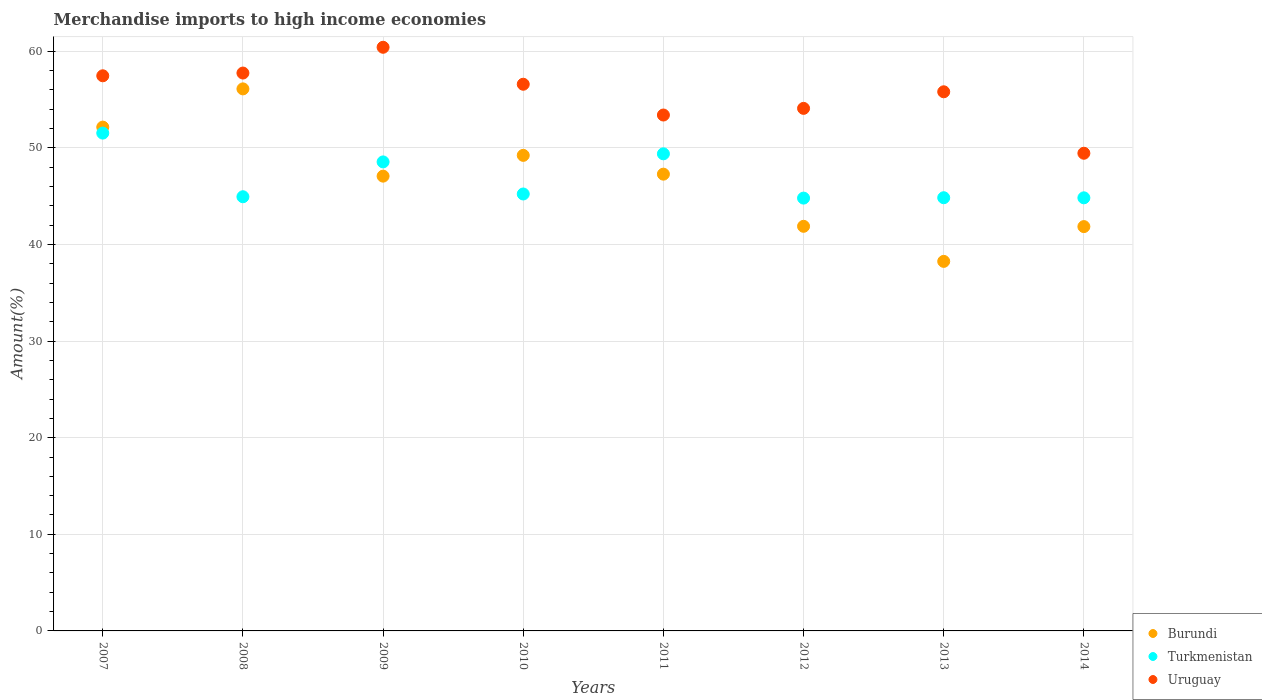How many different coloured dotlines are there?
Ensure brevity in your answer.  3. What is the percentage of amount earned from merchandise imports in Burundi in 2010?
Offer a very short reply. 49.22. Across all years, what is the maximum percentage of amount earned from merchandise imports in Burundi?
Ensure brevity in your answer.  56.1. Across all years, what is the minimum percentage of amount earned from merchandise imports in Uruguay?
Keep it short and to the point. 49.44. In which year was the percentage of amount earned from merchandise imports in Uruguay maximum?
Your answer should be very brief. 2009. What is the total percentage of amount earned from merchandise imports in Burundi in the graph?
Give a very brief answer. 373.78. What is the difference between the percentage of amount earned from merchandise imports in Uruguay in 2008 and that in 2011?
Make the answer very short. 4.34. What is the difference between the percentage of amount earned from merchandise imports in Burundi in 2013 and the percentage of amount earned from merchandise imports in Uruguay in 2012?
Your answer should be very brief. -15.84. What is the average percentage of amount earned from merchandise imports in Burundi per year?
Give a very brief answer. 46.72. In the year 2007, what is the difference between the percentage of amount earned from merchandise imports in Uruguay and percentage of amount earned from merchandise imports in Burundi?
Make the answer very short. 5.31. What is the ratio of the percentage of amount earned from merchandise imports in Turkmenistan in 2010 to that in 2014?
Make the answer very short. 1.01. Is the percentage of amount earned from merchandise imports in Burundi in 2013 less than that in 2014?
Provide a succinct answer. Yes. What is the difference between the highest and the second highest percentage of amount earned from merchandise imports in Turkmenistan?
Make the answer very short. 2.14. What is the difference between the highest and the lowest percentage of amount earned from merchandise imports in Uruguay?
Your answer should be compact. 10.97. In how many years, is the percentage of amount earned from merchandise imports in Burundi greater than the average percentage of amount earned from merchandise imports in Burundi taken over all years?
Make the answer very short. 5. Is the sum of the percentage of amount earned from merchandise imports in Burundi in 2011 and 2013 greater than the maximum percentage of amount earned from merchandise imports in Turkmenistan across all years?
Offer a terse response. Yes. Does the percentage of amount earned from merchandise imports in Turkmenistan monotonically increase over the years?
Your answer should be compact. No. Is the percentage of amount earned from merchandise imports in Uruguay strictly greater than the percentage of amount earned from merchandise imports in Burundi over the years?
Your response must be concise. Yes. How many dotlines are there?
Offer a very short reply. 3. What is the title of the graph?
Offer a very short reply. Merchandise imports to high income economies. Does "United Arab Emirates" appear as one of the legend labels in the graph?
Offer a terse response. No. What is the label or title of the Y-axis?
Your answer should be very brief. Amount(%). What is the Amount(%) in Burundi in 2007?
Provide a succinct answer. 52.14. What is the Amount(%) of Turkmenistan in 2007?
Your answer should be very brief. 51.52. What is the Amount(%) of Uruguay in 2007?
Your answer should be very brief. 57.46. What is the Amount(%) of Burundi in 2008?
Make the answer very short. 56.1. What is the Amount(%) of Turkmenistan in 2008?
Your response must be concise. 44.94. What is the Amount(%) in Uruguay in 2008?
Ensure brevity in your answer.  57.74. What is the Amount(%) in Burundi in 2009?
Your answer should be very brief. 47.07. What is the Amount(%) of Turkmenistan in 2009?
Offer a terse response. 48.54. What is the Amount(%) in Uruguay in 2009?
Ensure brevity in your answer.  60.41. What is the Amount(%) in Burundi in 2010?
Offer a very short reply. 49.22. What is the Amount(%) in Turkmenistan in 2010?
Provide a short and direct response. 45.22. What is the Amount(%) of Uruguay in 2010?
Keep it short and to the point. 56.58. What is the Amount(%) of Burundi in 2011?
Offer a very short reply. 47.27. What is the Amount(%) of Turkmenistan in 2011?
Offer a terse response. 49.38. What is the Amount(%) of Uruguay in 2011?
Offer a very short reply. 53.39. What is the Amount(%) in Burundi in 2012?
Provide a succinct answer. 41.88. What is the Amount(%) of Turkmenistan in 2012?
Provide a succinct answer. 44.8. What is the Amount(%) of Uruguay in 2012?
Make the answer very short. 54.08. What is the Amount(%) of Burundi in 2013?
Your response must be concise. 38.25. What is the Amount(%) of Turkmenistan in 2013?
Ensure brevity in your answer.  44.84. What is the Amount(%) in Uruguay in 2013?
Your response must be concise. 55.8. What is the Amount(%) in Burundi in 2014?
Your answer should be compact. 41.85. What is the Amount(%) in Turkmenistan in 2014?
Your response must be concise. 44.83. What is the Amount(%) in Uruguay in 2014?
Provide a short and direct response. 49.44. Across all years, what is the maximum Amount(%) of Burundi?
Offer a very short reply. 56.1. Across all years, what is the maximum Amount(%) of Turkmenistan?
Your answer should be very brief. 51.52. Across all years, what is the maximum Amount(%) of Uruguay?
Provide a short and direct response. 60.41. Across all years, what is the minimum Amount(%) in Burundi?
Your answer should be compact. 38.25. Across all years, what is the minimum Amount(%) of Turkmenistan?
Your answer should be compact. 44.8. Across all years, what is the minimum Amount(%) in Uruguay?
Your answer should be compact. 49.44. What is the total Amount(%) of Burundi in the graph?
Offer a terse response. 373.78. What is the total Amount(%) in Turkmenistan in the graph?
Ensure brevity in your answer.  374.06. What is the total Amount(%) in Uruguay in the graph?
Keep it short and to the point. 444.9. What is the difference between the Amount(%) of Burundi in 2007 and that in 2008?
Offer a very short reply. -3.96. What is the difference between the Amount(%) of Turkmenistan in 2007 and that in 2008?
Offer a very short reply. 6.59. What is the difference between the Amount(%) of Uruguay in 2007 and that in 2008?
Give a very brief answer. -0.28. What is the difference between the Amount(%) in Burundi in 2007 and that in 2009?
Your answer should be very brief. 5.07. What is the difference between the Amount(%) in Turkmenistan in 2007 and that in 2009?
Your answer should be very brief. 2.98. What is the difference between the Amount(%) of Uruguay in 2007 and that in 2009?
Offer a very short reply. -2.95. What is the difference between the Amount(%) of Burundi in 2007 and that in 2010?
Keep it short and to the point. 2.92. What is the difference between the Amount(%) in Turkmenistan in 2007 and that in 2010?
Offer a terse response. 6.3. What is the difference between the Amount(%) in Uruguay in 2007 and that in 2010?
Offer a very short reply. 0.88. What is the difference between the Amount(%) of Burundi in 2007 and that in 2011?
Offer a terse response. 4.87. What is the difference between the Amount(%) of Turkmenistan in 2007 and that in 2011?
Your response must be concise. 2.14. What is the difference between the Amount(%) of Uruguay in 2007 and that in 2011?
Provide a succinct answer. 4.06. What is the difference between the Amount(%) of Burundi in 2007 and that in 2012?
Your answer should be compact. 10.27. What is the difference between the Amount(%) in Turkmenistan in 2007 and that in 2012?
Your answer should be very brief. 6.73. What is the difference between the Amount(%) of Uruguay in 2007 and that in 2012?
Offer a very short reply. 3.37. What is the difference between the Amount(%) in Burundi in 2007 and that in 2013?
Offer a very short reply. 13.9. What is the difference between the Amount(%) in Turkmenistan in 2007 and that in 2013?
Keep it short and to the point. 6.69. What is the difference between the Amount(%) in Uruguay in 2007 and that in 2013?
Provide a short and direct response. 1.66. What is the difference between the Amount(%) of Burundi in 2007 and that in 2014?
Keep it short and to the point. 10.3. What is the difference between the Amount(%) of Turkmenistan in 2007 and that in 2014?
Offer a terse response. 6.7. What is the difference between the Amount(%) of Uruguay in 2007 and that in 2014?
Keep it short and to the point. 8.02. What is the difference between the Amount(%) in Burundi in 2008 and that in 2009?
Provide a short and direct response. 9.03. What is the difference between the Amount(%) in Turkmenistan in 2008 and that in 2009?
Your response must be concise. -3.61. What is the difference between the Amount(%) of Uruguay in 2008 and that in 2009?
Your response must be concise. -2.67. What is the difference between the Amount(%) of Burundi in 2008 and that in 2010?
Provide a short and direct response. 6.88. What is the difference between the Amount(%) of Turkmenistan in 2008 and that in 2010?
Offer a terse response. -0.29. What is the difference between the Amount(%) in Uruguay in 2008 and that in 2010?
Give a very brief answer. 1.16. What is the difference between the Amount(%) in Burundi in 2008 and that in 2011?
Give a very brief answer. 8.83. What is the difference between the Amount(%) of Turkmenistan in 2008 and that in 2011?
Your answer should be compact. -4.44. What is the difference between the Amount(%) in Uruguay in 2008 and that in 2011?
Provide a succinct answer. 4.34. What is the difference between the Amount(%) of Burundi in 2008 and that in 2012?
Provide a short and direct response. 14.22. What is the difference between the Amount(%) of Turkmenistan in 2008 and that in 2012?
Give a very brief answer. 0.14. What is the difference between the Amount(%) in Uruguay in 2008 and that in 2012?
Offer a terse response. 3.66. What is the difference between the Amount(%) in Burundi in 2008 and that in 2013?
Make the answer very short. 17.85. What is the difference between the Amount(%) in Turkmenistan in 2008 and that in 2013?
Give a very brief answer. 0.1. What is the difference between the Amount(%) of Uruguay in 2008 and that in 2013?
Your answer should be compact. 1.94. What is the difference between the Amount(%) of Burundi in 2008 and that in 2014?
Your response must be concise. 14.25. What is the difference between the Amount(%) of Turkmenistan in 2008 and that in 2014?
Your answer should be compact. 0.11. What is the difference between the Amount(%) of Uruguay in 2008 and that in 2014?
Provide a succinct answer. 8.3. What is the difference between the Amount(%) in Burundi in 2009 and that in 2010?
Keep it short and to the point. -2.15. What is the difference between the Amount(%) of Turkmenistan in 2009 and that in 2010?
Make the answer very short. 3.32. What is the difference between the Amount(%) in Uruguay in 2009 and that in 2010?
Keep it short and to the point. 3.83. What is the difference between the Amount(%) of Burundi in 2009 and that in 2011?
Keep it short and to the point. -0.2. What is the difference between the Amount(%) of Turkmenistan in 2009 and that in 2011?
Ensure brevity in your answer.  -0.84. What is the difference between the Amount(%) in Uruguay in 2009 and that in 2011?
Provide a short and direct response. 7.01. What is the difference between the Amount(%) of Burundi in 2009 and that in 2012?
Your answer should be very brief. 5.19. What is the difference between the Amount(%) in Turkmenistan in 2009 and that in 2012?
Make the answer very short. 3.75. What is the difference between the Amount(%) in Uruguay in 2009 and that in 2012?
Ensure brevity in your answer.  6.32. What is the difference between the Amount(%) of Burundi in 2009 and that in 2013?
Provide a succinct answer. 8.82. What is the difference between the Amount(%) of Turkmenistan in 2009 and that in 2013?
Offer a terse response. 3.71. What is the difference between the Amount(%) of Uruguay in 2009 and that in 2013?
Make the answer very short. 4.61. What is the difference between the Amount(%) of Burundi in 2009 and that in 2014?
Your response must be concise. 5.22. What is the difference between the Amount(%) of Turkmenistan in 2009 and that in 2014?
Ensure brevity in your answer.  3.72. What is the difference between the Amount(%) in Uruguay in 2009 and that in 2014?
Your response must be concise. 10.97. What is the difference between the Amount(%) of Burundi in 2010 and that in 2011?
Ensure brevity in your answer.  1.95. What is the difference between the Amount(%) of Turkmenistan in 2010 and that in 2011?
Your response must be concise. -4.16. What is the difference between the Amount(%) in Uruguay in 2010 and that in 2011?
Provide a succinct answer. 3.19. What is the difference between the Amount(%) in Burundi in 2010 and that in 2012?
Your answer should be compact. 7.34. What is the difference between the Amount(%) in Turkmenistan in 2010 and that in 2012?
Offer a terse response. 0.43. What is the difference between the Amount(%) in Uruguay in 2010 and that in 2012?
Your response must be concise. 2.5. What is the difference between the Amount(%) of Burundi in 2010 and that in 2013?
Offer a very short reply. 10.97. What is the difference between the Amount(%) of Turkmenistan in 2010 and that in 2013?
Provide a succinct answer. 0.39. What is the difference between the Amount(%) of Uruguay in 2010 and that in 2013?
Offer a terse response. 0.78. What is the difference between the Amount(%) of Burundi in 2010 and that in 2014?
Your response must be concise. 7.37. What is the difference between the Amount(%) in Turkmenistan in 2010 and that in 2014?
Your answer should be compact. 0.4. What is the difference between the Amount(%) of Uruguay in 2010 and that in 2014?
Ensure brevity in your answer.  7.14. What is the difference between the Amount(%) in Burundi in 2011 and that in 2012?
Make the answer very short. 5.4. What is the difference between the Amount(%) in Turkmenistan in 2011 and that in 2012?
Offer a terse response. 4.58. What is the difference between the Amount(%) of Uruguay in 2011 and that in 2012?
Provide a succinct answer. -0.69. What is the difference between the Amount(%) in Burundi in 2011 and that in 2013?
Provide a short and direct response. 9.03. What is the difference between the Amount(%) of Turkmenistan in 2011 and that in 2013?
Keep it short and to the point. 4.54. What is the difference between the Amount(%) in Uruguay in 2011 and that in 2013?
Give a very brief answer. -2.41. What is the difference between the Amount(%) of Burundi in 2011 and that in 2014?
Keep it short and to the point. 5.43. What is the difference between the Amount(%) of Turkmenistan in 2011 and that in 2014?
Your answer should be very brief. 4.55. What is the difference between the Amount(%) in Uruguay in 2011 and that in 2014?
Make the answer very short. 3.96. What is the difference between the Amount(%) in Burundi in 2012 and that in 2013?
Your answer should be very brief. 3.63. What is the difference between the Amount(%) of Turkmenistan in 2012 and that in 2013?
Offer a terse response. -0.04. What is the difference between the Amount(%) of Uruguay in 2012 and that in 2013?
Offer a terse response. -1.72. What is the difference between the Amount(%) in Burundi in 2012 and that in 2014?
Give a very brief answer. 0.03. What is the difference between the Amount(%) of Turkmenistan in 2012 and that in 2014?
Provide a short and direct response. -0.03. What is the difference between the Amount(%) of Uruguay in 2012 and that in 2014?
Provide a succinct answer. 4.65. What is the difference between the Amount(%) of Burundi in 2013 and that in 2014?
Keep it short and to the point. -3.6. What is the difference between the Amount(%) of Turkmenistan in 2013 and that in 2014?
Provide a succinct answer. 0.01. What is the difference between the Amount(%) in Uruguay in 2013 and that in 2014?
Your answer should be compact. 6.36. What is the difference between the Amount(%) in Burundi in 2007 and the Amount(%) in Turkmenistan in 2008?
Offer a terse response. 7.21. What is the difference between the Amount(%) of Burundi in 2007 and the Amount(%) of Uruguay in 2008?
Make the answer very short. -5.6. What is the difference between the Amount(%) in Turkmenistan in 2007 and the Amount(%) in Uruguay in 2008?
Make the answer very short. -6.22. What is the difference between the Amount(%) of Burundi in 2007 and the Amount(%) of Turkmenistan in 2009?
Offer a terse response. 3.6. What is the difference between the Amount(%) in Burundi in 2007 and the Amount(%) in Uruguay in 2009?
Make the answer very short. -8.26. What is the difference between the Amount(%) in Turkmenistan in 2007 and the Amount(%) in Uruguay in 2009?
Your answer should be very brief. -8.88. What is the difference between the Amount(%) of Burundi in 2007 and the Amount(%) of Turkmenistan in 2010?
Your response must be concise. 6.92. What is the difference between the Amount(%) in Burundi in 2007 and the Amount(%) in Uruguay in 2010?
Your answer should be very brief. -4.44. What is the difference between the Amount(%) of Turkmenistan in 2007 and the Amount(%) of Uruguay in 2010?
Offer a terse response. -5.06. What is the difference between the Amount(%) in Burundi in 2007 and the Amount(%) in Turkmenistan in 2011?
Provide a short and direct response. 2.76. What is the difference between the Amount(%) in Burundi in 2007 and the Amount(%) in Uruguay in 2011?
Provide a succinct answer. -1.25. What is the difference between the Amount(%) of Turkmenistan in 2007 and the Amount(%) of Uruguay in 2011?
Your answer should be compact. -1.87. What is the difference between the Amount(%) of Burundi in 2007 and the Amount(%) of Turkmenistan in 2012?
Provide a short and direct response. 7.35. What is the difference between the Amount(%) in Burundi in 2007 and the Amount(%) in Uruguay in 2012?
Keep it short and to the point. -1.94. What is the difference between the Amount(%) of Turkmenistan in 2007 and the Amount(%) of Uruguay in 2012?
Provide a short and direct response. -2.56. What is the difference between the Amount(%) of Burundi in 2007 and the Amount(%) of Turkmenistan in 2013?
Offer a very short reply. 7.31. What is the difference between the Amount(%) of Burundi in 2007 and the Amount(%) of Uruguay in 2013?
Ensure brevity in your answer.  -3.66. What is the difference between the Amount(%) of Turkmenistan in 2007 and the Amount(%) of Uruguay in 2013?
Offer a terse response. -4.28. What is the difference between the Amount(%) in Burundi in 2007 and the Amount(%) in Turkmenistan in 2014?
Your answer should be very brief. 7.32. What is the difference between the Amount(%) of Burundi in 2007 and the Amount(%) of Uruguay in 2014?
Offer a very short reply. 2.7. What is the difference between the Amount(%) of Turkmenistan in 2007 and the Amount(%) of Uruguay in 2014?
Offer a very short reply. 2.09. What is the difference between the Amount(%) in Burundi in 2008 and the Amount(%) in Turkmenistan in 2009?
Your answer should be very brief. 7.56. What is the difference between the Amount(%) in Burundi in 2008 and the Amount(%) in Uruguay in 2009?
Make the answer very short. -4.31. What is the difference between the Amount(%) in Turkmenistan in 2008 and the Amount(%) in Uruguay in 2009?
Your response must be concise. -15.47. What is the difference between the Amount(%) of Burundi in 2008 and the Amount(%) of Turkmenistan in 2010?
Keep it short and to the point. 10.88. What is the difference between the Amount(%) of Burundi in 2008 and the Amount(%) of Uruguay in 2010?
Make the answer very short. -0.48. What is the difference between the Amount(%) in Turkmenistan in 2008 and the Amount(%) in Uruguay in 2010?
Provide a short and direct response. -11.64. What is the difference between the Amount(%) in Burundi in 2008 and the Amount(%) in Turkmenistan in 2011?
Your answer should be compact. 6.72. What is the difference between the Amount(%) of Burundi in 2008 and the Amount(%) of Uruguay in 2011?
Provide a succinct answer. 2.71. What is the difference between the Amount(%) in Turkmenistan in 2008 and the Amount(%) in Uruguay in 2011?
Make the answer very short. -8.46. What is the difference between the Amount(%) in Burundi in 2008 and the Amount(%) in Turkmenistan in 2012?
Give a very brief answer. 11.3. What is the difference between the Amount(%) in Burundi in 2008 and the Amount(%) in Uruguay in 2012?
Keep it short and to the point. 2.02. What is the difference between the Amount(%) in Turkmenistan in 2008 and the Amount(%) in Uruguay in 2012?
Offer a terse response. -9.15. What is the difference between the Amount(%) of Burundi in 2008 and the Amount(%) of Turkmenistan in 2013?
Your response must be concise. 11.27. What is the difference between the Amount(%) in Burundi in 2008 and the Amount(%) in Uruguay in 2013?
Provide a short and direct response. 0.3. What is the difference between the Amount(%) in Turkmenistan in 2008 and the Amount(%) in Uruguay in 2013?
Offer a very short reply. -10.86. What is the difference between the Amount(%) of Burundi in 2008 and the Amount(%) of Turkmenistan in 2014?
Offer a terse response. 11.28. What is the difference between the Amount(%) of Burundi in 2008 and the Amount(%) of Uruguay in 2014?
Keep it short and to the point. 6.66. What is the difference between the Amount(%) of Turkmenistan in 2008 and the Amount(%) of Uruguay in 2014?
Keep it short and to the point. -4.5. What is the difference between the Amount(%) of Burundi in 2009 and the Amount(%) of Turkmenistan in 2010?
Provide a short and direct response. 1.85. What is the difference between the Amount(%) of Burundi in 2009 and the Amount(%) of Uruguay in 2010?
Give a very brief answer. -9.51. What is the difference between the Amount(%) of Turkmenistan in 2009 and the Amount(%) of Uruguay in 2010?
Provide a short and direct response. -8.04. What is the difference between the Amount(%) in Burundi in 2009 and the Amount(%) in Turkmenistan in 2011?
Make the answer very short. -2.31. What is the difference between the Amount(%) in Burundi in 2009 and the Amount(%) in Uruguay in 2011?
Offer a very short reply. -6.33. What is the difference between the Amount(%) in Turkmenistan in 2009 and the Amount(%) in Uruguay in 2011?
Provide a succinct answer. -4.85. What is the difference between the Amount(%) of Burundi in 2009 and the Amount(%) of Turkmenistan in 2012?
Provide a succinct answer. 2.27. What is the difference between the Amount(%) in Burundi in 2009 and the Amount(%) in Uruguay in 2012?
Keep it short and to the point. -7.01. What is the difference between the Amount(%) in Turkmenistan in 2009 and the Amount(%) in Uruguay in 2012?
Ensure brevity in your answer.  -5.54. What is the difference between the Amount(%) of Burundi in 2009 and the Amount(%) of Turkmenistan in 2013?
Provide a short and direct response. 2.23. What is the difference between the Amount(%) in Burundi in 2009 and the Amount(%) in Uruguay in 2013?
Keep it short and to the point. -8.73. What is the difference between the Amount(%) in Turkmenistan in 2009 and the Amount(%) in Uruguay in 2013?
Your answer should be very brief. -7.26. What is the difference between the Amount(%) in Burundi in 2009 and the Amount(%) in Turkmenistan in 2014?
Your answer should be very brief. 2.24. What is the difference between the Amount(%) in Burundi in 2009 and the Amount(%) in Uruguay in 2014?
Make the answer very short. -2.37. What is the difference between the Amount(%) of Turkmenistan in 2009 and the Amount(%) of Uruguay in 2014?
Make the answer very short. -0.9. What is the difference between the Amount(%) in Burundi in 2010 and the Amount(%) in Turkmenistan in 2011?
Your answer should be very brief. -0.16. What is the difference between the Amount(%) of Burundi in 2010 and the Amount(%) of Uruguay in 2011?
Provide a succinct answer. -4.17. What is the difference between the Amount(%) in Turkmenistan in 2010 and the Amount(%) in Uruguay in 2011?
Your answer should be very brief. -8.17. What is the difference between the Amount(%) of Burundi in 2010 and the Amount(%) of Turkmenistan in 2012?
Keep it short and to the point. 4.42. What is the difference between the Amount(%) in Burundi in 2010 and the Amount(%) in Uruguay in 2012?
Provide a succinct answer. -4.86. What is the difference between the Amount(%) in Turkmenistan in 2010 and the Amount(%) in Uruguay in 2012?
Keep it short and to the point. -8.86. What is the difference between the Amount(%) of Burundi in 2010 and the Amount(%) of Turkmenistan in 2013?
Give a very brief answer. 4.38. What is the difference between the Amount(%) in Burundi in 2010 and the Amount(%) in Uruguay in 2013?
Provide a short and direct response. -6.58. What is the difference between the Amount(%) in Turkmenistan in 2010 and the Amount(%) in Uruguay in 2013?
Your answer should be very brief. -10.58. What is the difference between the Amount(%) in Burundi in 2010 and the Amount(%) in Turkmenistan in 2014?
Ensure brevity in your answer.  4.39. What is the difference between the Amount(%) of Burundi in 2010 and the Amount(%) of Uruguay in 2014?
Ensure brevity in your answer.  -0.22. What is the difference between the Amount(%) of Turkmenistan in 2010 and the Amount(%) of Uruguay in 2014?
Ensure brevity in your answer.  -4.22. What is the difference between the Amount(%) in Burundi in 2011 and the Amount(%) in Turkmenistan in 2012?
Provide a succinct answer. 2.48. What is the difference between the Amount(%) of Burundi in 2011 and the Amount(%) of Uruguay in 2012?
Offer a very short reply. -6.81. What is the difference between the Amount(%) in Turkmenistan in 2011 and the Amount(%) in Uruguay in 2012?
Your answer should be compact. -4.7. What is the difference between the Amount(%) in Burundi in 2011 and the Amount(%) in Turkmenistan in 2013?
Offer a very short reply. 2.44. What is the difference between the Amount(%) in Burundi in 2011 and the Amount(%) in Uruguay in 2013?
Make the answer very short. -8.53. What is the difference between the Amount(%) of Turkmenistan in 2011 and the Amount(%) of Uruguay in 2013?
Make the answer very short. -6.42. What is the difference between the Amount(%) of Burundi in 2011 and the Amount(%) of Turkmenistan in 2014?
Provide a succinct answer. 2.45. What is the difference between the Amount(%) of Burundi in 2011 and the Amount(%) of Uruguay in 2014?
Your response must be concise. -2.16. What is the difference between the Amount(%) of Turkmenistan in 2011 and the Amount(%) of Uruguay in 2014?
Your answer should be compact. -0.06. What is the difference between the Amount(%) of Burundi in 2012 and the Amount(%) of Turkmenistan in 2013?
Offer a terse response. -2.96. What is the difference between the Amount(%) of Burundi in 2012 and the Amount(%) of Uruguay in 2013?
Your answer should be compact. -13.92. What is the difference between the Amount(%) of Turkmenistan in 2012 and the Amount(%) of Uruguay in 2013?
Offer a terse response. -11. What is the difference between the Amount(%) of Burundi in 2012 and the Amount(%) of Turkmenistan in 2014?
Provide a short and direct response. -2.95. What is the difference between the Amount(%) in Burundi in 2012 and the Amount(%) in Uruguay in 2014?
Your answer should be compact. -7.56. What is the difference between the Amount(%) in Turkmenistan in 2012 and the Amount(%) in Uruguay in 2014?
Give a very brief answer. -4.64. What is the difference between the Amount(%) in Burundi in 2013 and the Amount(%) in Turkmenistan in 2014?
Give a very brief answer. -6.58. What is the difference between the Amount(%) of Burundi in 2013 and the Amount(%) of Uruguay in 2014?
Your answer should be very brief. -11.19. What is the difference between the Amount(%) in Turkmenistan in 2013 and the Amount(%) in Uruguay in 2014?
Your answer should be compact. -4.6. What is the average Amount(%) in Burundi per year?
Your answer should be compact. 46.72. What is the average Amount(%) of Turkmenistan per year?
Give a very brief answer. 46.76. What is the average Amount(%) of Uruguay per year?
Your response must be concise. 55.61. In the year 2007, what is the difference between the Amount(%) of Burundi and Amount(%) of Turkmenistan?
Offer a very short reply. 0.62. In the year 2007, what is the difference between the Amount(%) of Burundi and Amount(%) of Uruguay?
Offer a very short reply. -5.31. In the year 2007, what is the difference between the Amount(%) in Turkmenistan and Amount(%) in Uruguay?
Give a very brief answer. -5.93. In the year 2008, what is the difference between the Amount(%) in Burundi and Amount(%) in Turkmenistan?
Your answer should be compact. 11.16. In the year 2008, what is the difference between the Amount(%) in Burundi and Amount(%) in Uruguay?
Make the answer very short. -1.64. In the year 2008, what is the difference between the Amount(%) in Turkmenistan and Amount(%) in Uruguay?
Offer a very short reply. -12.8. In the year 2009, what is the difference between the Amount(%) in Burundi and Amount(%) in Turkmenistan?
Your answer should be very brief. -1.47. In the year 2009, what is the difference between the Amount(%) of Burundi and Amount(%) of Uruguay?
Provide a succinct answer. -13.34. In the year 2009, what is the difference between the Amount(%) in Turkmenistan and Amount(%) in Uruguay?
Your answer should be very brief. -11.86. In the year 2010, what is the difference between the Amount(%) in Burundi and Amount(%) in Turkmenistan?
Offer a terse response. 4. In the year 2010, what is the difference between the Amount(%) in Burundi and Amount(%) in Uruguay?
Provide a short and direct response. -7.36. In the year 2010, what is the difference between the Amount(%) of Turkmenistan and Amount(%) of Uruguay?
Give a very brief answer. -11.36. In the year 2011, what is the difference between the Amount(%) in Burundi and Amount(%) in Turkmenistan?
Your response must be concise. -2.1. In the year 2011, what is the difference between the Amount(%) in Burundi and Amount(%) in Uruguay?
Keep it short and to the point. -6.12. In the year 2011, what is the difference between the Amount(%) of Turkmenistan and Amount(%) of Uruguay?
Offer a very short reply. -4.02. In the year 2012, what is the difference between the Amount(%) of Burundi and Amount(%) of Turkmenistan?
Make the answer very short. -2.92. In the year 2012, what is the difference between the Amount(%) in Burundi and Amount(%) in Uruguay?
Keep it short and to the point. -12.21. In the year 2012, what is the difference between the Amount(%) of Turkmenistan and Amount(%) of Uruguay?
Offer a terse response. -9.29. In the year 2013, what is the difference between the Amount(%) of Burundi and Amount(%) of Turkmenistan?
Give a very brief answer. -6.59. In the year 2013, what is the difference between the Amount(%) in Burundi and Amount(%) in Uruguay?
Ensure brevity in your answer.  -17.55. In the year 2013, what is the difference between the Amount(%) of Turkmenistan and Amount(%) of Uruguay?
Offer a very short reply. -10.96. In the year 2014, what is the difference between the Amount(%) in Burundi and Amount(%) in Turkmenistan?
Ensure brevity in your answer.  -2.98. In the year 2014, what is the difference between the Amount(%) in Burundi and Amount(%) in Uruguay?
Provide a short and direct response. -7.59. In the year 2014, what is the difference between the Amount(%) in Turkmenistan and Amount(%) in Uruguay?
Provide a short and direct response. -4.61. What is the ratio of the Amount(%) in Burundi in 2007 to that in 2008?
Make the answer very short. 0.93. What is the ratio of the Amount(%) in Turkmenistan in 2007 to that in 2008?
Keep it short and to the point. 1.15. What is the ratio of the Amount(%) in Burundi in 2007 to that in 2009?
Provide a succinct answer. 1.11. What is the ratio of the Amount(%) of Turkmenistan in 2007 to that in 2009?
Offer a terse response. 1.06. What is the ratio of the Amount(%) of Uruguay in 2007 to that in 2009?
Ensure brevity in your answer.  0.95. What is the ratio of the Amount(%) in Burundi in 2007 to that in 2010?
Your answer should be compact. 1.06. What is the ratio of the Amount(%) of Turkmenistan in 2007 to that in 2010?
Your answer should be very brief. 1.14. What is the ratio of the Amount(%) in Uruguay in 2007 to that in 2010?
Make the answer very short. 1.02. What is the ratio of the Amount(%) of Burundi in 2007 to that in 2011?
Your answer should be very brief. 1.1. What is the ratio of the Amount(%) in Turkmenistan in 2007 to that in 2011?
Give a very brief answer. 1.04. What is the ratio of the Amount(%) of Uruguay in 2007 to that in 2011?
Offer a very short reply. 1.08. What is the ratio of the Amount(%) in Burundi in 2007 to that in 2012?
Ensure brevity in your answer.  1.25. What is the ratio of the Amount(%) in Turkmenistan in 2007 to that in 2012?
Give a very brief answer. 1.15. What is the ratio of the Amount(%) in Uruguay in 2007 to that in 2012?
Your response must be concise. 1.06. What is the ratio of the Amount(%) of Burundi in 2007 to that in 2013?
Your answer should be very brief. 1.36. What is the ratio of the Amount(%) in Turkmenistan in 2007 to that in 2013?
Your answer should be compact. 1.15. What is the ratio of the Amount(%) in Uruguay in 2007 to that in 2013?
Your answer should be compact. 1.03. What is the ratio of the Amount(%) of Burundi in 2007 to that in 2014?
Provide a short and direct response. 1.25. What is the ratio of the Amount(%) of Turkmenistan in 2007 to that in 2014?
Make the answer very short. 1.15. What is the ratio of the Amount(%) of Uruguay in 2007 to that in 2014?
Make the answer very short. 1.16. What is the ratio of the Amount(%) of Burundi in 2008 to that in 2009?
Make the answer very short. 1.19. What is the ratio of the Amount(%) of Turkmenistan in 2008 to that in 2009?
Make the answer very short. 0.93. What is the ratio of the Amount(%) in Uruguay in 2008 to that in 2009?
Make the answer very short. 0.96. What is the ratio of the Amount(%) of Burundi in 2008 to that in 2010?
Provide a short and direct response. 1.14. What is the ratio of the Amount(%) in Turkmenistan in 2008 to that in 2010?
Offer a terse response. 0.99. What is the ratio of the Amount(%) in Uruguay in 2008 to that in 2010?
Make the answer very short. 1.02. What is the ratio of the Amount(%) in Burundi in 2008 to that in 2011?
Make the answer very short. 1.19. What is the ratio of the Amount(%) of Turkmenistan in 2008 to that in 2011?
Your response must be concise. 0.91. What is the ratio of the Amount(%) of Uruguay in 2008 to that in 2011?
Your response must be concise. 1.08. What is the ratio of the Amount(%) of Burundi in 2008 to that in 2012?
Ensure brevity in your answer.  1.34. What is the ratio of the Amount(%) in Turkmenistan in 2008 to that in 2012?
Make the answer very short. 1. What is the ratio of the Amount(%) in Uruguay in 2008 to that in 2012?
Offer a very short reply. 1.07. What is the ratio of the Amount(%) of Burundi in 2008 to that in 2013?
Provide a short and direct response. 1.47. What is the ratio of the Amount(%) in Uruguay in 2008 to that in 2013?
Provide a short and direct response. 1.03. What is the ratio of the Amount(%) in Burundi in 2008 to that in 2014?
Offer a terse response. 1.34. What is the ratio of the Amount(%) of Turkmenistan in 2008 to that in 2014?
Provide a short and direct response. 1. What is the ratio of the Amount(%) in Uruguay in 2008 to that in 2014?
Provide a short and direct response. 1.17. What is the ratio of the Amount(%) in Burundi in 2009 to that in 2010?
Offer a terse response. 0.96. What is the ratio of the Amount(%) in Turkmenistan in 2009 to that in 2010?
Ensure brevity in your answer.  1.07. What is the ratio of the Amount(%) of Uruguay in 2009 to that in 2010?
Make the answer very short. 1.07. What is the ratio of the Amount(%) of Burundi in 2009 to that in 2011?
Ensure brevity in your answer.  1. What is the ratio of the Amount(%) in Turkmenistan in 2009 to that in 2011?
Provide a succinct answer. 0.98. What is the ratio of the Amount(%) in Uruguay in 2009 to that in 2011?
Ensure brevity in your answer.  1.13. What is the ratio of the Amount(%) in Burundi in 2009 to that in 2012?
Ensure brevity in your answer.  1.12. What is the ratio of the Amount(%) of Turkmenistan in 2009 to that in 2012?
Provide a succinct answer. 1.08. What is the ratio of the Amount(%) of Uruguay in 2009 to that in 2012?
Ensure brevity in your answer.  1.12. What is the ratio of the Amount(%) in Burundi in 2009 to that in 2013?
Ensure brevity in your answer.  1.23. What is the ratio of the Amount(%) of Turkmenistan in 2009 to that in 2013?
Your answer should be very brief. 1.08. What is the ratio of the Amount(%) of Uruguay in 2009 to that in 2013?
Your response must be concise. 1.08. What is the ratio of the Amount(%) of Burundi in 2009 to that in 2014?
Keep it short and to the point. 1.12. What is the ratio of the Amount(%) in Turkmenistan in 2009 to that in 2014?
Your answer should be compact. 1.08. What is the ratio of the Amount(%) of Uruguay in 2009 to that in 2014?
Make the answer very short. 1.22. What is the ratio of the Amount(%) of Burundi in 2010 to that in 2011?
Provide a short and direct response. 1.04. What is the ratio of the Amount(%) in Turkmenistan in 2010 to that in 2011?
Your response must be concise. 0.92. What is the ratio of the Amount(%) in Uruguay in 2010 to that in 2011?
Your answer should be compact. 1.06. What is the ratio of the Amount(%) of Burundi in 2010 to that in 2012?
Provide a short and direct response. 1.18. What is the ratio of the Amount(%) of Turkmenistan in 2010 to that in 2012?
Offer a terse response. 1.01. What is the ratio of the Amount(%) of Uruguay in 2010 to that in 2012?
Provide a short and direct response. 1.05. What is the ratio of the Amount(%) of Burundi in 2010 to that in 2013?
Provide a short and direct response. 1.29. What is the ratio of the Amount(%) of Turkmenistan in 2010 to that in 2013?
Make the answer very short. 1.01. What is the ratio of the Amount(%) of Burundi in 2010 to that in 2014?
Offer a terse response. 1.18. What is the ratio of the Amount(%) of Turkmenistan in 2010 to that in 2014?
Make the answer very short. 1.01. What is the ratio of the Amount(%) of Uruguay in 2010 to that in 2014?
Make the answer very short. 1.14. What is the ratio of the Amount(%) in Burundi in 2011 to that in 2012?
Make the answer very short. 1.13. What is the ratio of the Amount(%) of Turkmenistan in 2011 to that in 2012?
Your response must be concise. 1.1. What is the ratio of the Amount(%) in Uruguay in 2011 to that in 2012?
Offer a terse response. 0.99. What is the ratio of the Amount(%) in Burundi in 2011 to that in 2013?
Your response must be concise. 1.24. What is the ratio of the Amount(%) in Turkmenistan in 2011 to that in 2013?
Offer a very short reply. 1.1. What is the ratio of the Amount(%) of Uruguay in 2011 to that in 2013?
Your response must be concise. 0.96. What is the ratio of the Amount(%) of Burundi in 2011 to that in 2014?
Keep it short and to the point. 1.13. What is the ratio of the Amount(%) in Turkmenistan in 2011 to that in 2014?
Make the answer very short. 1.1. What is the ratio of the Amount(%) of Uruguay in 2011 to that in 2014?
Your answer should be compact. 1.08. What is the ratio of the Amount(%) in Burundi in 2012 to that in 2013?
Make the answer very short. 1.09. What is the ratio of the Amount(%) of Turkmenistan in 2012 to that in 2013?
Provide a succinct answer. 1. What is the ratio of the Amount(%) of Uruguay in 2012 to that in 2013?
Your response must be concise. 0.97. What is the ratio of the Amount(%) in Turkmenistan in 2012 to that in 2014?
Give a very brief answer. 1. What is the ratio of the Amount(%) of Uruguay in 2012 to that in 2014?
Keep it short and to the point. 1.09. What is the ratio of the Amount(%) in Burundi in 2013 to that in 2014?
Offer a very short reply. 0.91. What is the ratio of the Amount(%) of Turkmenistan in 2013 to that in 2014?
Give a very brief answer. 1. What is the ratio of the Amount(%) of Uruguay in 2013 to that in 2014?
Your answer should be compact. 1.13. What is the difference between the highest and the second highest Amount(%) in Burundi?
Ensure brevity in your answer.  3.96. What is the difference between the highest and the second highest Amount(%) in Turkmenistan?
Offer a very short reply. 2.14. What is the difference between the highest and the second highest Amount(%) of Uruguay?
Provide a short and direct response. 2.67. What is the difference between the highest and the lowest Amount(%) in Burundi?
Give a very brief answer. 17.85. What is the difference between the highest and the lowest Amount(%) in Turkmenistan?
Offer a very short reply. 6.73. What is the difference between the highest and the lowest Amount(%) of Uruguay?
Keep it short and to the point. 10.97. 